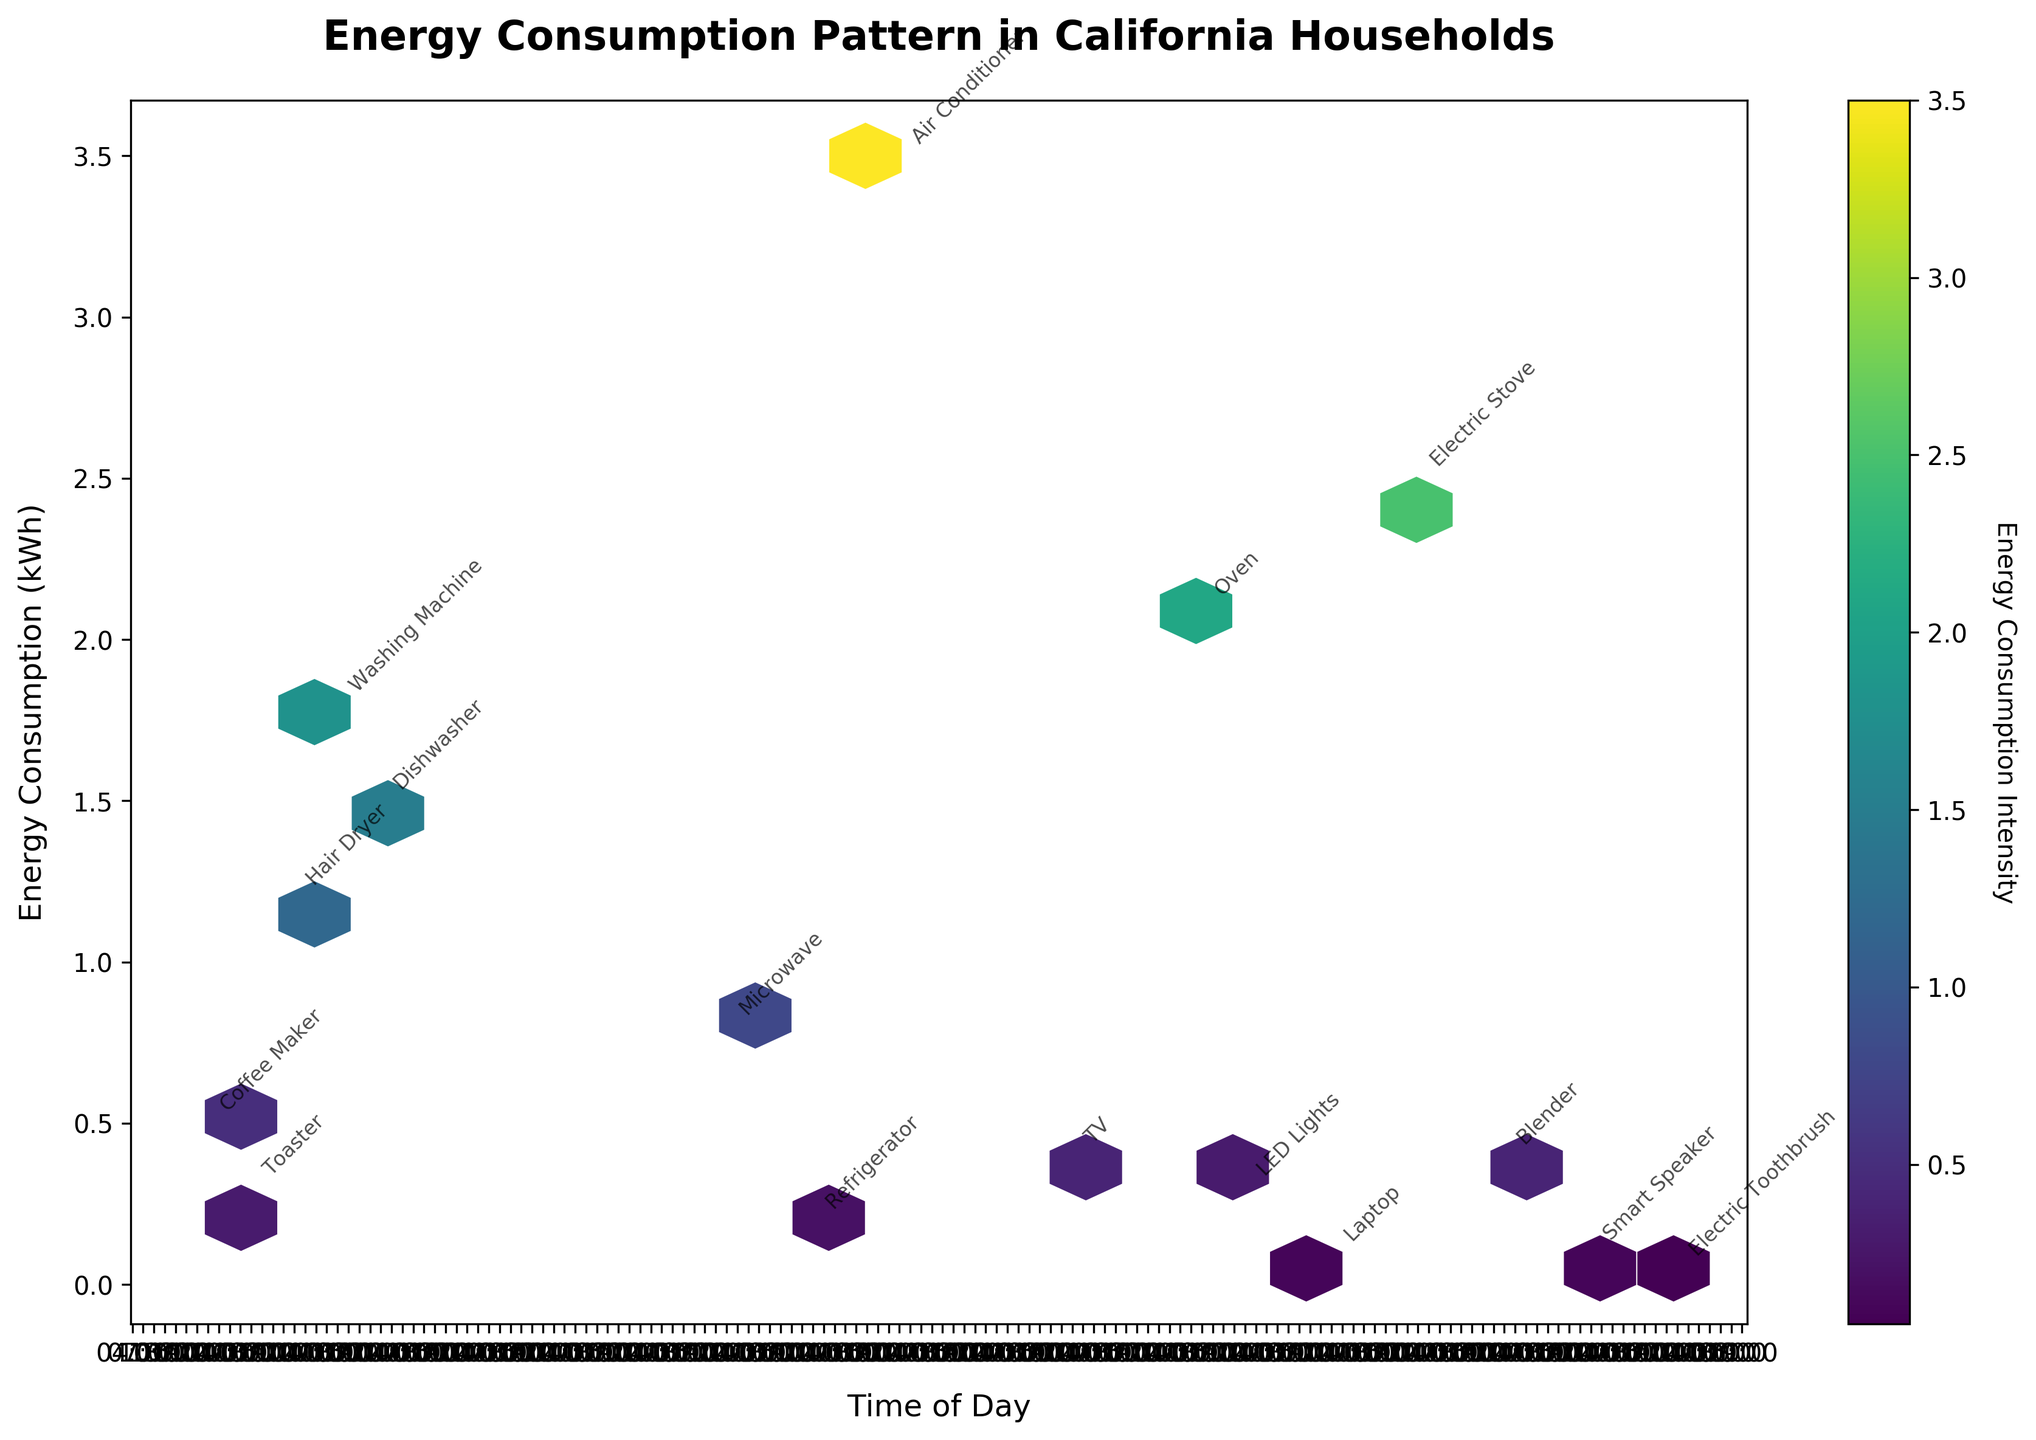1. What is the title of the plot? The title is displayed at the top of the figure and serves to inform the viewer about the topic of the plot. In this case, it describes what is being analyzed.
Answer: Energy Consumption Pattern in California Households 2. How is the x-axis labeled? The x-axis label is found below the x-axis itself. It provides information about what the horizontal axis represents in the plot.
Answer: Time of Day 3. How many appliances are there in total? Each point in the plot is annotated with the name of an appliance. By counting each unique annotation, we can determine the number of appliances represented.
Answer: 16 4. Which appliance has the highest energy consumption, and at what time? The appliance with the highest energy consumption will be located at the topmost point of the plot. Reading the annotation next to this point will give us the answer.
Answer: Air Conditioner, 14:00 5. At what time is the energy consumption of the Electric Stove? Locate the annotation "Electric Stove" on the plot to find its corresponding time by looking at its position on the x-axis.
Answer: 20:00 6. What is the range of hours displayed on the x-axis? The plot shows the x-axis scale which represents the time of the day. Observing the starting and ending points on the x-axis will provide the range of hours.
Answer: 6:00 to 23:00 7. Compare the energy consumption of the Dishwasher and the Oven. Which one consumes more energy? Locate the points and annotations for both the Dishwasher and the Oven on the plot, then compare their positions on the y-axis to determine which one is higher.
Answer: Oven 8. What can be said about the intensity of energy consumption across different times of the day? The color intensity in a hexbin plot represents the density of energy consumption. Observing which parts of the plot have darker colors can reveal patterns in energy use throughout the day.
Answer: Higher in the afternoon and evening 9. How does the energy consumption at 7:00 compare to that at 8:00? Find the points annotated with the appliances used at 7:00 and 8:00, then compare their positions on the y-axis to understand the difference in energy consumption between these times.
Answer: 7:00 is higher 10. What pattern can you observe from the appliances used during early morning hours vs. late evening hours? By examining the points and annotations displayed at the beginning (early morning) and end (late evening) of the time range on the x-axis, look for differences in energy consumption patterns or type of appliances used.
Answer: Lower energy consumption in the evening 